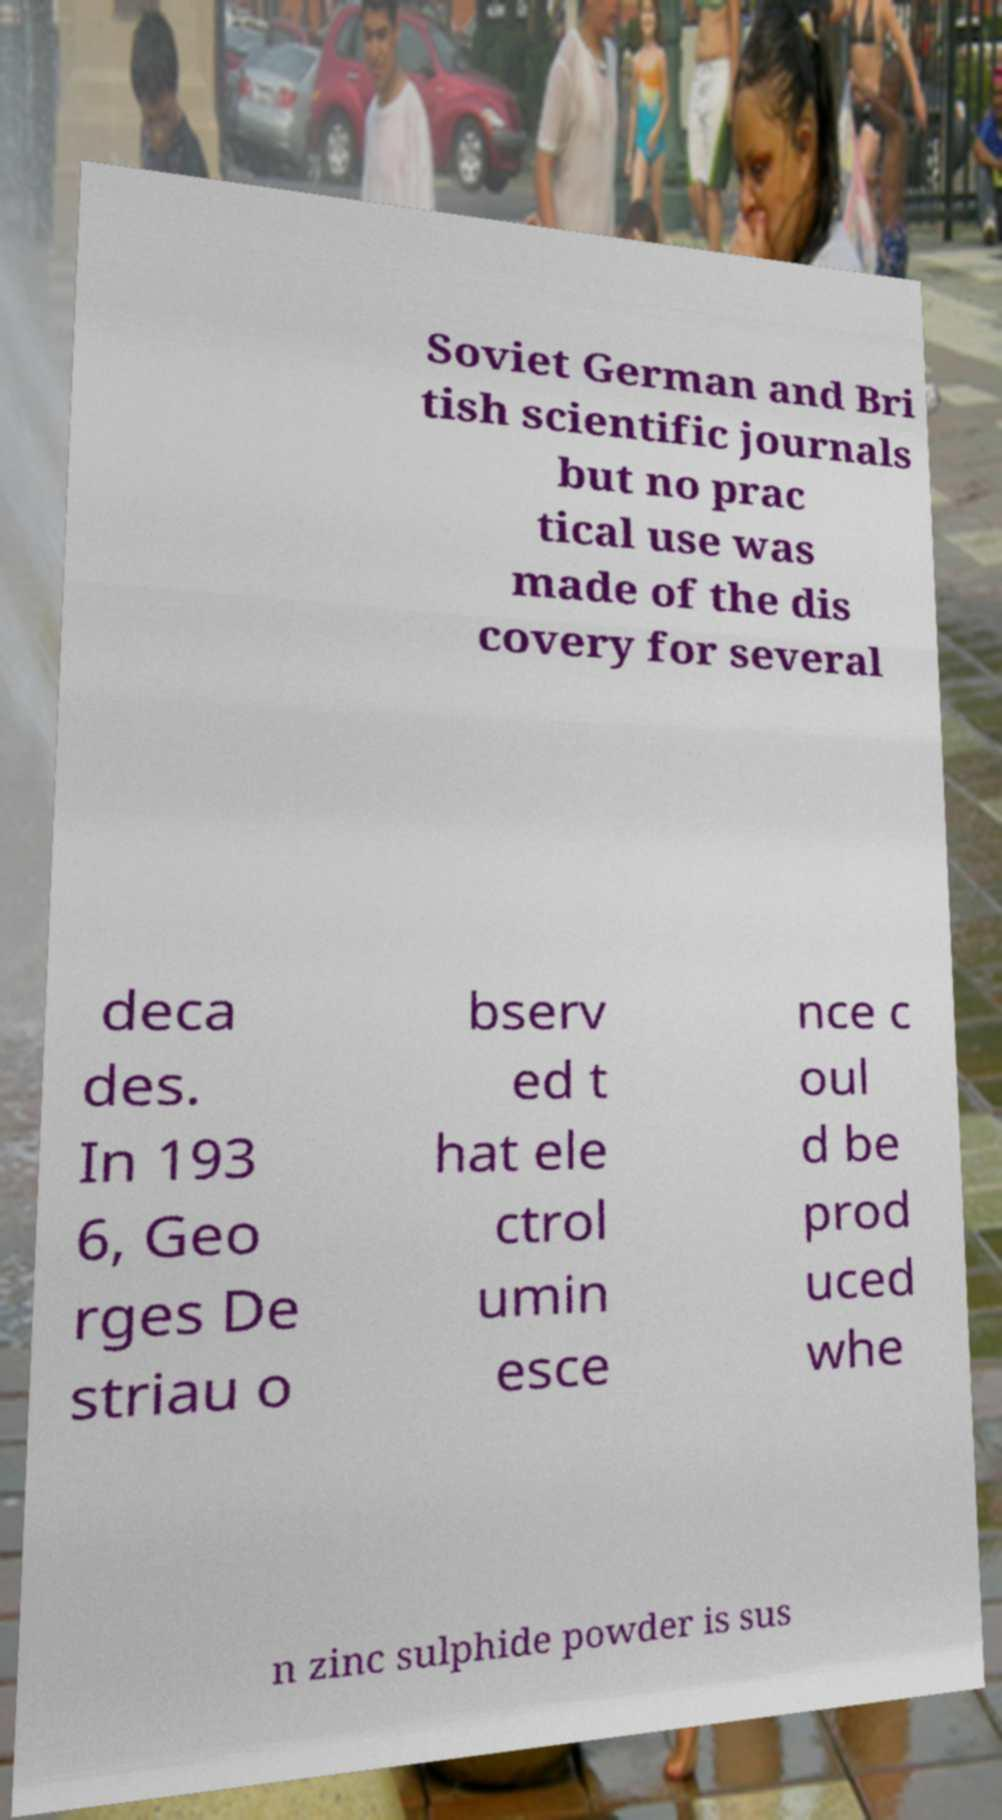I need the written content from this picture converted into text. Can you do that? Soviet German and Bri tish scientific journals but no prac tical use was made of the dis covery for several deca des. In 193 6, Geo rges De striau o bserv ed t hat ele ctrol umin esce nce c oul d be prod uced whe n zinc sulphide powder is sus 